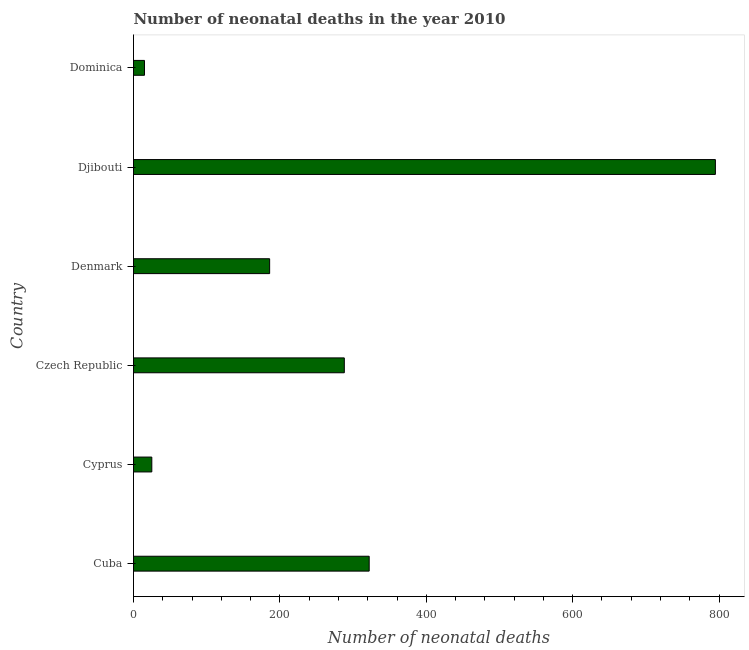Does the graph contain grids?
Make the answer very short. No. What is the title of the graph?
Offer a terse response. Number of neonatal deaths in the year 2010. What is the label or title of the X-axis?
Provide a succinct answer. Number of neonatal deaths. What is the number of neonatal deaths in Dominica?
Your answer should be compact. 15. Across all countries, what is the maximum number of neonatal deaths?
Provide a succinct answer. 795. In which country was the number of neonatal deaths maximum?
Provide a short and direct response. Djibouti. In which country was the number of neonatal deaths minimum?
Keep it short and to the point. Dominica. What is the sum of the number of neonatal deaths?
Keep it short and to the point. 1631. What is the difference between the number of neonatal deaths in Cyprus and Djibouti?
Provide a succinct answer. -770. What is the average number of neonatal deaths per country?
Make the answer very short. 271. What is the median number of neonatal deaths?
Provide a succinct answer. 237. In how many countries, is the number of neonatal deaths greater than 240 ?
Your answer should be very brief. 3. What is the ratio of the number of neonatal deaths in Cuba to that in Djibouti?
Provide a short and direct response. 0.41. Is the number of neonatal deaths in Djibouti less than that in Dominica?
Your answer should be compact. No. Is the difference between the number of neonatal deaths in Cyprus and Dominica greater than the difference between any two countries?
Give a very brief answer. No. What is the difference between the highest and the second highest number of neonatal deaths?
Offer a terse response. 473. What is the difference between the highest and the lowest number of neonatal deaths?
Give a very brief answer. 780. Are the values on the major ticks of X-axis written in scientific E-notation?
Give a very brief answer. No. What is the Number of neonatal deaths of Cuba?
Make the answer very short. 322. What is the Number of neonatal deaths in Cyprus?
Offer a terse response. 25. What is the Number of neonatal deaths in Czech Republic?
Give a very brief answer. 288. What is the Number of neonatal deaths of Denmark?
Offer a terse response. 186. What is the Number of neonatal deaths in Djibouti?
Your answer should be very brief. 795. What is the Number of neonatal deaths of Dominica?
Offer a very short reply. 15. What is the difference between the Number of neonatal deaths in Cuba and Cyprus?
Provide a succinct answer. 297. What is the difference between the Number of neonatal deaths in Cuba and Denmark?
Your answer should be very brief. 136. What is the difference between the Number of neonatal deaths in Cuba and Djibouti?
Provide a succinct answer. -473. What is the difference between the Number of neonatal deaths in Cuba and Dominica?
Give a very brief answer. 307. What is the difference between the Number of neonatal deaths in Cyprus and Czech Republic?
Provide a succinct answer. -263. What is the difference between the Number of neonatal deaths in Cyprus and Denmark?
Give a very brief answer. -161. What is the difference between the Number of neonatal deaths in Cyprus and Djibouti?
Offer a very short reply. -770. What is the difference between the Number of neonatal deaths in Czech Republic and Denmark?
Provide a succinct answer. 102. What is the difference between the Number of neonatal deaths in Czech Republic and Djibouti?
Your answer should be compact. -507. What is the difference between the Number of neonatal deaths in Czech Republic and Dominica?
Your response must be concise. 273. What is the difference between the Number of neonatal deaths in Denmark and Djibouti?
Keep it short and to the point. -609. What is the difference between the Number of neonatal deaths in Denmark and Dominica?
Your answer should be compact. 171. What is the difference between the Number of neonatal deaths in Djibouti and Dominica?
Offer a terse response. 780. What is the ratio of the Number of neonatal deaths in Cuba to that in Cyprus?
Your answer should be very brief. 12.88. What is the ratio of the Number of neonatal deaths in Cuba to that in Czech Republic?
Keep it short and to the point. 1.12. What is the ratio of the Number of neonatal deaths in Cuba to that in Denmark?
Make the answer very short. 1.73. What is the ratio of the Number of neonatal deaths in Cuba to that in Djibouti?
Your answer should be very brief. 0.41. What is the ratio of the Number of neonatal deaths in Cuba to that in Dominica?
Provide a succinct answer. 21.47. What is the ratio of the Number of neonatal deaths in Cyprus to that in Czech Republic?
Provide a short and direct response. 0.09. What is the ratio of the Number of neonatal deaths in Cyprus to that in Denmark?
Offer a terse response. 0.13. What is the ratio of the Number of neonatal deaths in Cyprus to that in Djibouti?
Your answer should be very brief. 0.03. What is the ratio of the Number of neonatal deaths in Cyprus to that in Dominica?
Provide a short and direct response. 1.67. What is the ratio of the Number of neonatal deaths in Czech Republic to that in Denmark?
Make the answer very short. 1.55. What is the ratio of the Number of neonatal deaths in Czech Republic to that in Djibouti?
Provide a short and direct response. 0.36. What is the ratio of the Number of neonatal deaths in Czech Republic to that in Dominica?
Your answer should be very brief. 19.2. What is the ratio of the Number of neonatal deaths in Denmark to that in Djibouti?
Offer a terse response. 0.23. What is the ratio of the Number of neonatal deaths in Djibouti to that in Dominica?
Make the answer very short. 53. 